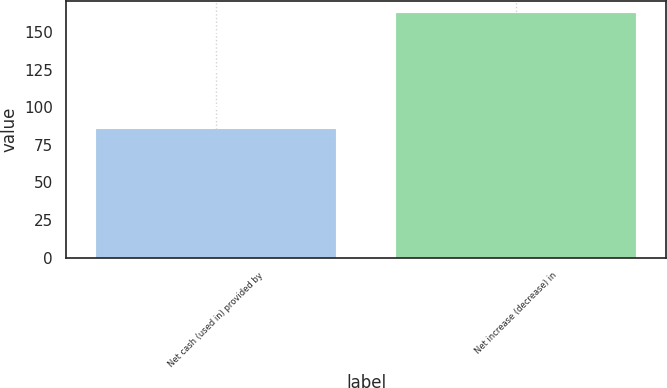Convert chart. <chart><loc_0><loc_0><loc_500><loc_500><bar_chart><fcel>Net cash (used in) provided by<fcel>Net increase (decrease) in<nl><fcel>85.7<fcel>162.6<nl></chart> 